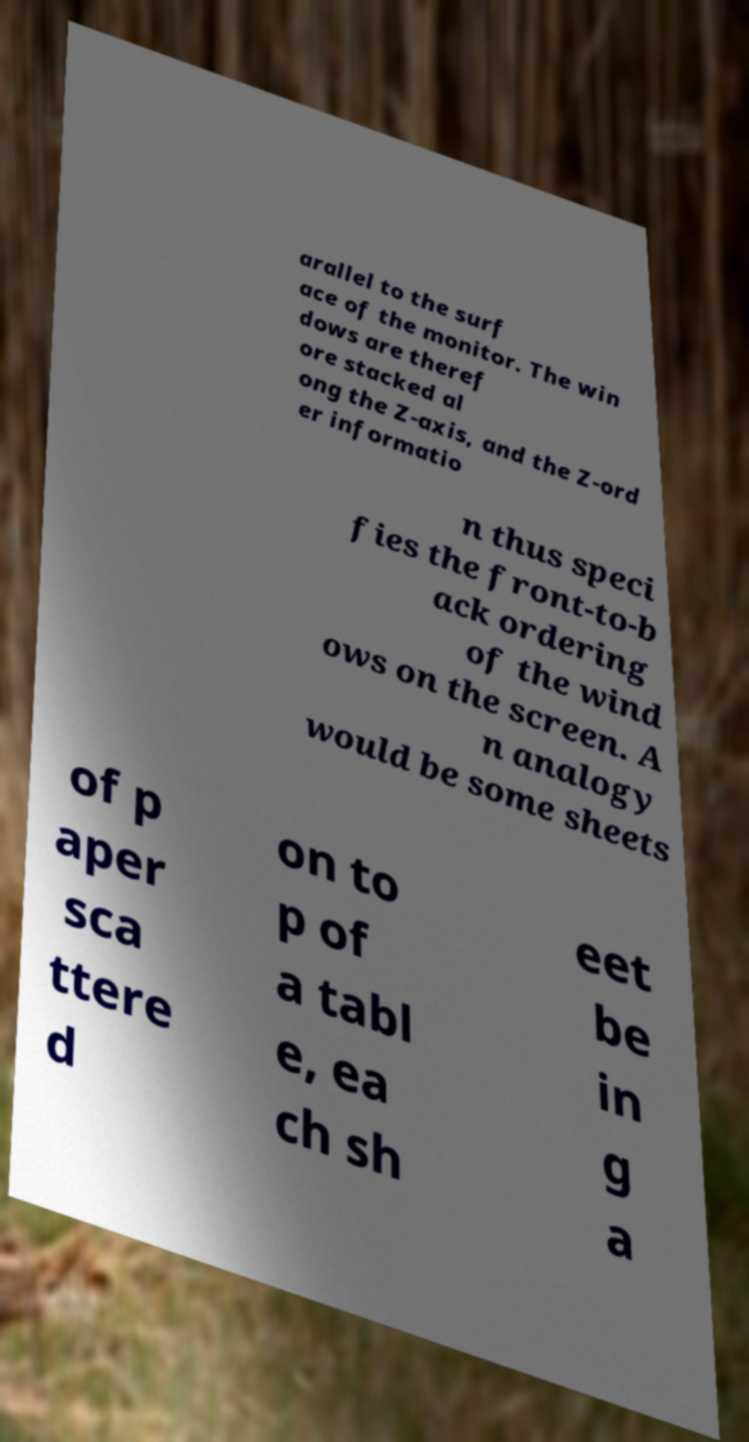Can you accurately transcribe the text from the provided image for me? arallel to the surf ace of the monitor. The win dows are theref ore stacked al ong the Z-axis, and the Z-ord er informatio n thus speci fies the front-to-b ack ordering of the wind ows on the screen. A n analogy would be some sheets of p aper sca ttere d on to p of a tabl e, ea ch sh eet be in g a 